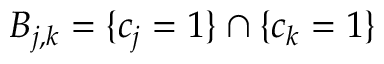Convert formula to latex. <formula><loc_0><loc_0><loc_500><loc_500>B _ { j , k } = \{ c _ { j } = 1 \} \cap \{ c _ { k } = 1 \}</formula> 